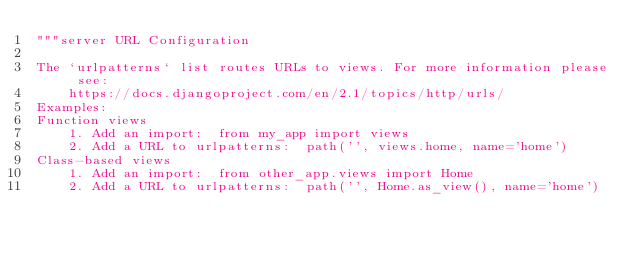<code> <loc_0><loc_0><loc_500><loc_500><_Python_>"""server URL Configuration

The `urlpatterns` list routes URLs to views. For more information please see:
    https://docs.djangoproject.com/en/2.1/topics/http/urls/
Examples:
Function views
    1. Add an import:  from my_app import views
    2. Add a URL to urlpatterns:  path('', views.home, name='home')
Class-based views
    1. Add an import:  from other_app.views import Home
    2. Add a URL to urlpatterns:  path('', Home.as_view(), name='home')</code> 